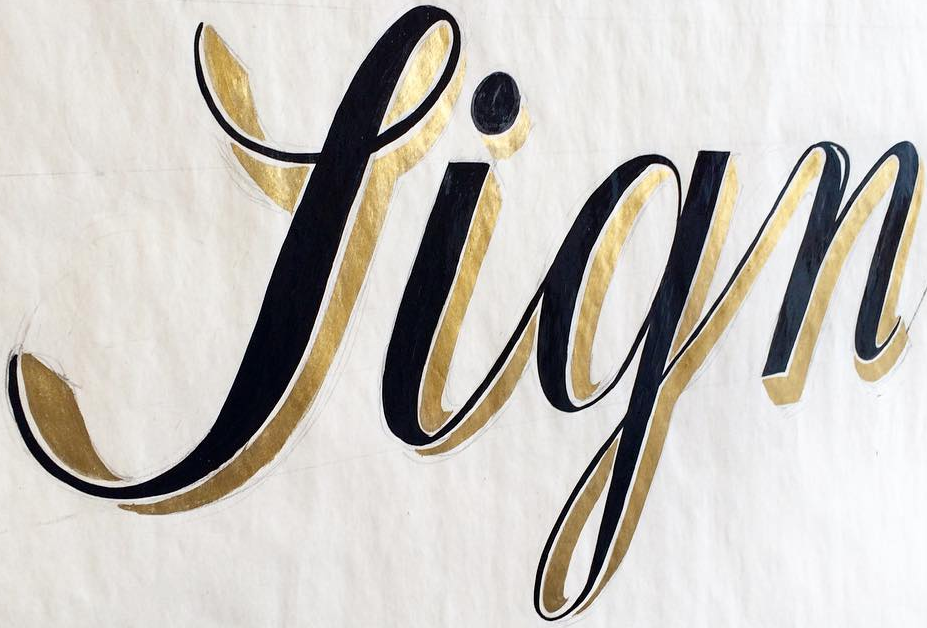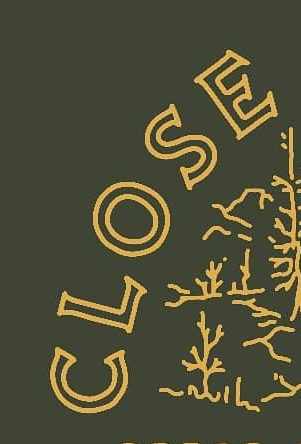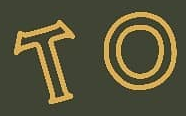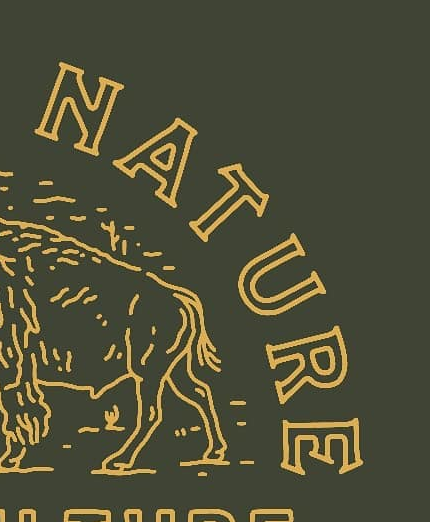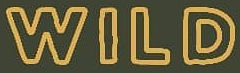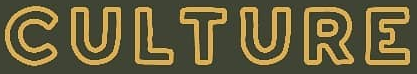What text appears in these images from left to right, separated by a semicolon? Sign; CLOSE; TO; NATURE; WILD; CULTURE 